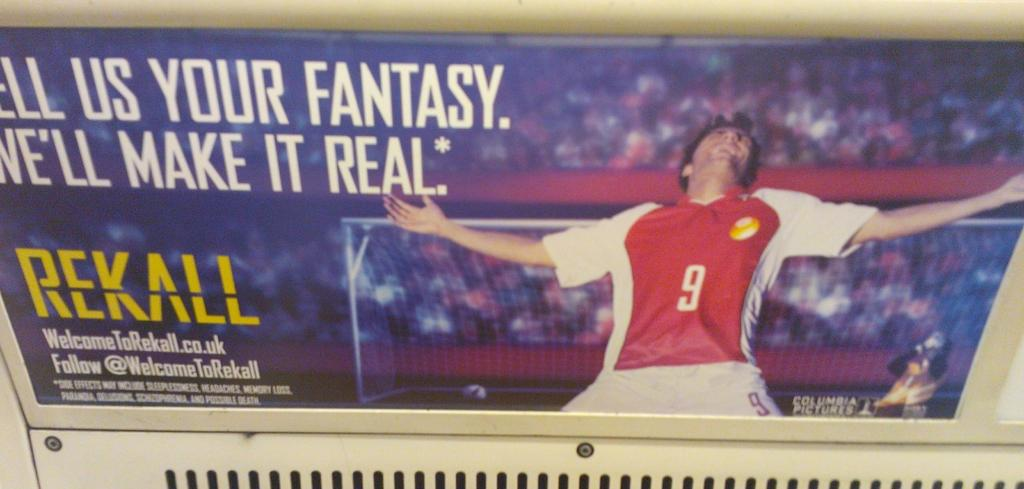<image>
Describe the image concisely. A soccer advertisement with a player wearing the number 9 jersey celebrating a goal. 